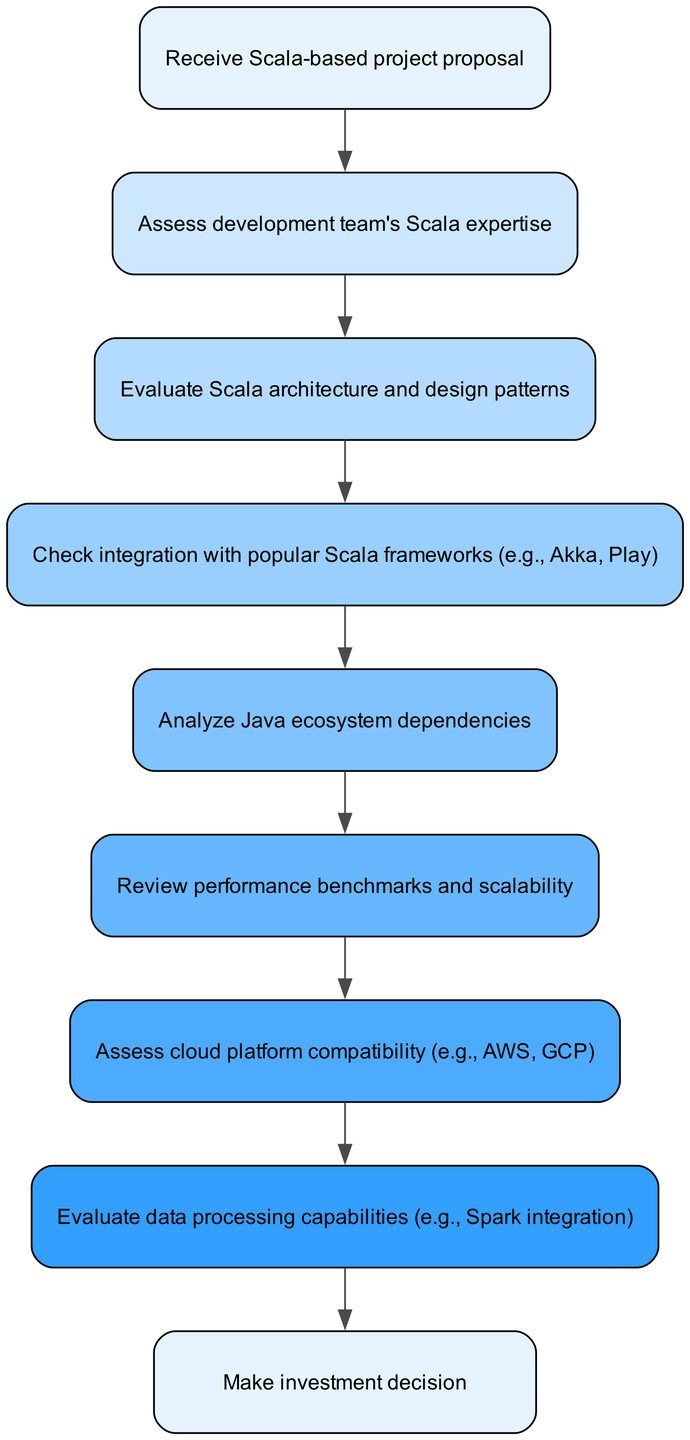What is the starting point of the workflow? The diagram indicates the first step is "Receive Scala-based project proposal," which is the initial action taken in the workflow.
Answer: Receive Scala-based project proposal How many nodes are in the diagram? By counting the nodes listed in the data, there are a total of 9 nodes present in the workflow, each representing a step in the evaluation process.
Answer: 9 What step follows assessing the team? After "Assess development team's Scala expertise," the next step in the flow is "Evaluate Scala architecture and design patterns," which directly follows this assessment.
Answer: Evaluate Scala architecture and design patterns What technology stack framework is specifically mentioned for integration checks? The diagram specifically mentions checking integration with popular Scala frameworks such as Akka and Play as part of the evaluation process.
Answer: Akka, Play What is the final decision in the workflow? The last node in the diagram signifies the final step with "Make investment decision," indicating the conclusion of the evaluation process where a decision is made based on the prior assessments.
Answer: Make investment decision How do performance benchmarks affect the process? Performance benchmarks come after analyzing dependencies, and their review is crucial for determining the scalability and efficiency of the Scala-based project, impacting the overall evaluation.
Answer: Review performance benchmarks and scalability Which step assesses cloud platform compatibility? The workflow directly moves from reviewing performance to "Assess cloud platform compatibility," indicating that the cloud aspects are considered next to the performance evaluations.
Answer: Assess cloud platform compatibility What node indicates data processing capabilities evaluation? The evaluation of data processing capabilities is represented by the node "Evaluate data processing capabilities," which checks for potential integration, such as with Spark, necessary for data-oriented functionality in projects.
Answer: Evaluate data processing capabilities 